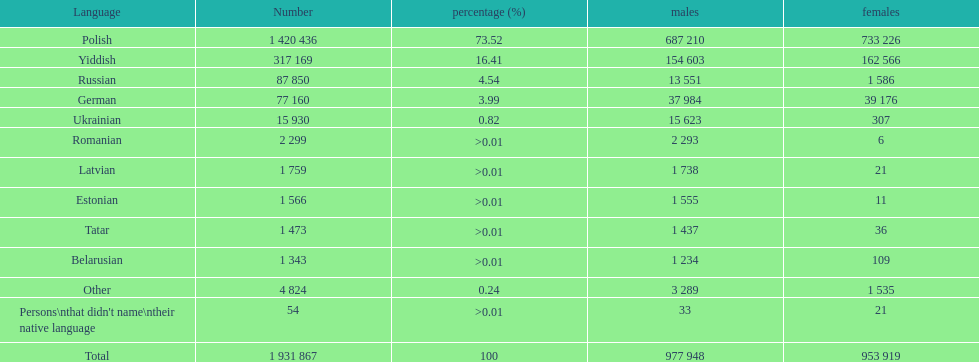Can you parse all the data within this table? {'header': ['Language', 'Number', 'percentage (%)', 'males', 'females'], 'rows': [['Polish', '1 420 436', '73.52', '687 210', '733 226'], ['Yiddish', '317 169', '16.41', '154 603', '162 566'], ['Russian', '87 850', '4.54', '13 551', '1 586'], ['German', '77 160', '3.99', '37 984', '39 176'], ['Ukrainian', '15 930', '0.82', '15 623', '307'], ['Romanian', '2 299', '>0.01', '2 293', '6'], ['Latvian', '1 759', '>0.01', '1 738', '21'], ['Estonian', '1 566', '>0.01', '1 555', '11'], ['Tatar', '1 473', '>0.01', '1 437', '36'], ['Belarusian', '1 343', '>0.01', '1 234', '109'], ['Other', '4 824', '0.24', '3 289', '1 535'], ["Persons\\nthat didn't name\\ntheir native language", '54', '>0.01', '33', '21'], ['Total', '1 931 867', '100', '977 948', '953 919']]} The smallest number of women Romanian. 